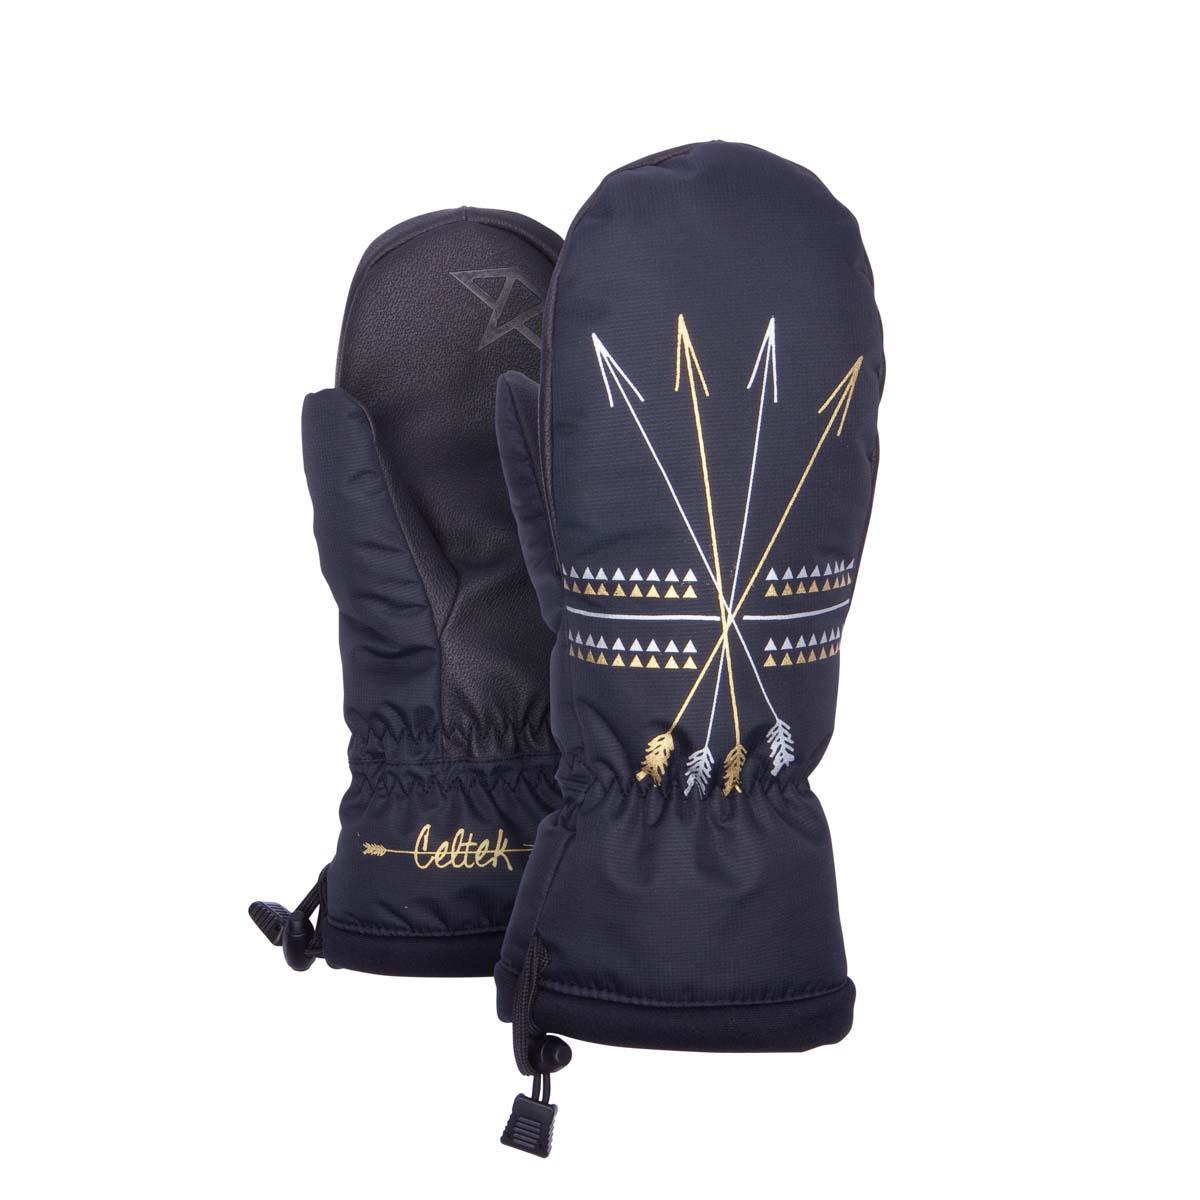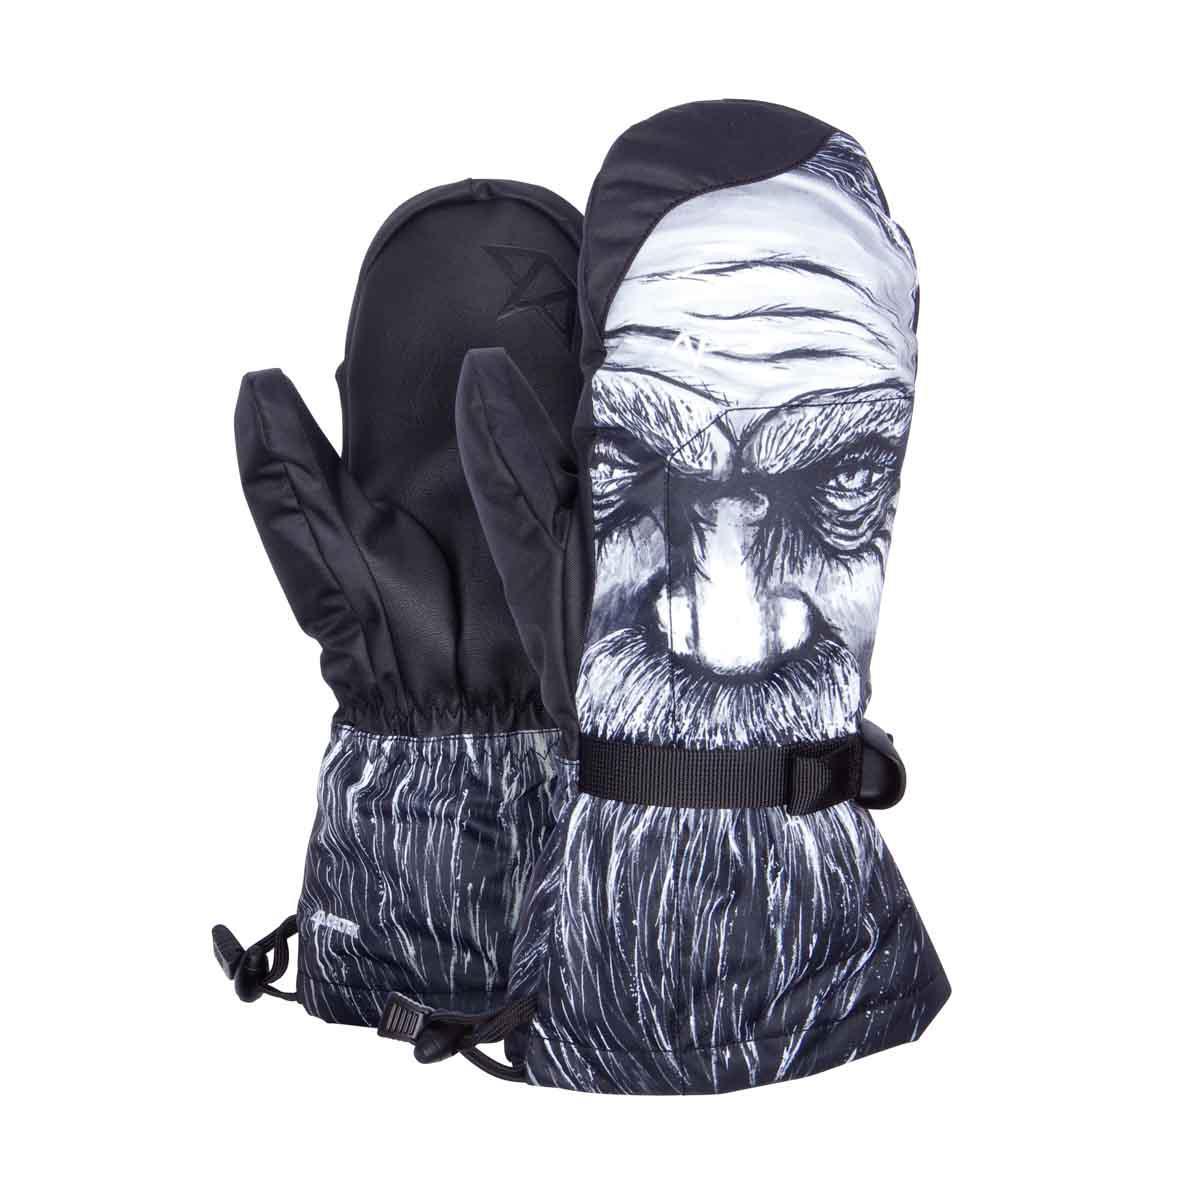The first image is the image on the left, the second image is the image on the right. Assess this claim about the two images: "The pattern on the mittens in the image on the right depict a nonhuman animal.". Correct or not? Answer yes or no. No. The first image is the image on the left, the second image is the image on the right. Considering the images on both sides, is "Each image shows one pair of mittens, and one of the mitten pairs has a realistic black-and-white nonhuman animal face depicted on its non-palm side." valid? Answer yes or no. No. 